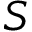Convert formula to latex. <formula><loc_0><loc_0><loc_500><loc_500>S</formula> 